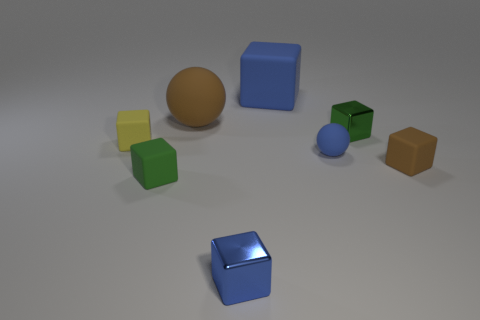Is the color of the large block the same as the small sphere?
Your response must be concise. Yes. There is a big object that is on the left side of the tiny blue object that is on the left side of the blue matte block; what number of brown rubber spheres are right of it?
Provide a short and direct response. 0. There is a large object that is the same shape as the tiny yellow object; what is its color?
Make the answer very short. Blue. What shape is the large object that is to the right of the small metal block that is in front of the small green cube that is on the right side of the large brown rubber thing?
Your answer should be compact. Cube. What size is the matte block that is to the right of the small yellow matte object and behind the blue rubber ball?
Your response must be concise. Large. Is the number of blue cubes less than the number of big purple rubber balls?
Your answer should be very brief. No. What is the size of the blue thing behind the yellow rubber cube?
Your answer should be compact. Large. There is a object that is both behind the small yellow object and to the left of the tiny blue shiny thing; what shape is it?
Keep it short and to the point. Sphere. There is a blue rubber object that is the same shape as the small yellow matte object; what is its size?
Provide a succinct answer. Large. How many brown spheres have the same material as the yellow block?
Make the answer very short. 1. 